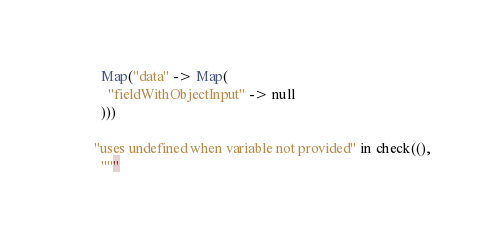<code> <loc_0><loc_0><loc_500><loc_500><_Scala_>          Map("data" -> Map(
            "fieldWithObjectInput" -> null
          )))

        "uses undefined when variable not provided" in check((),
          """</code> 